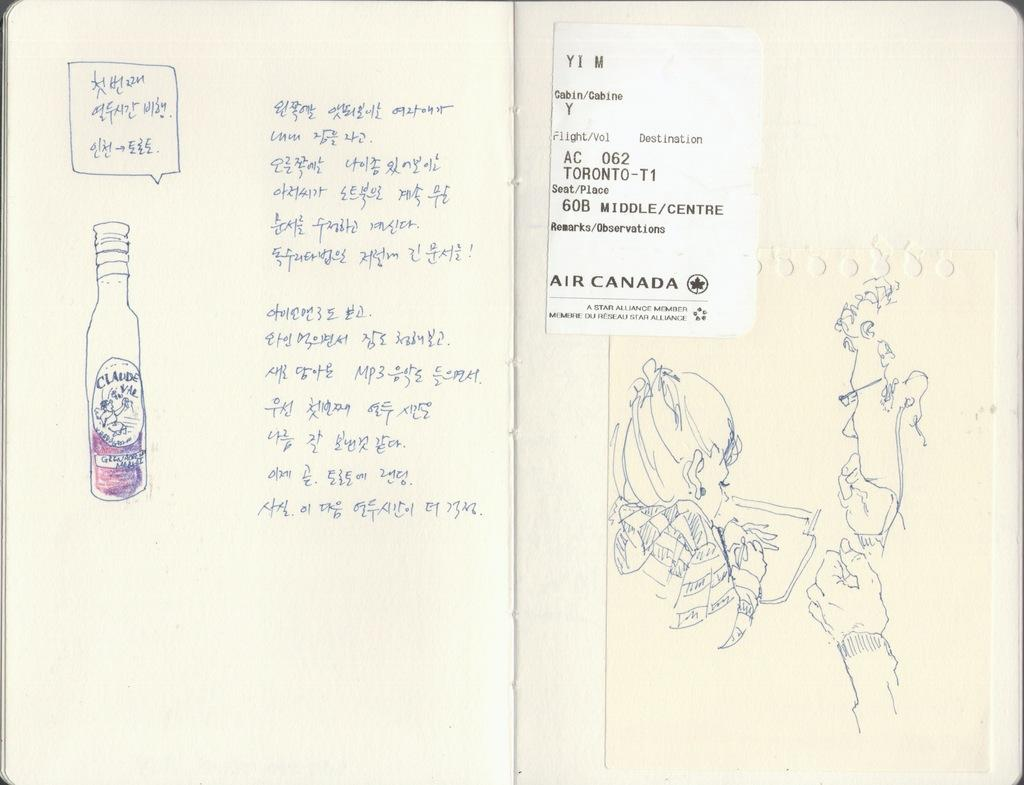<image>
Offer a succinct explanation of the picture presented. Foreign hand writing next to a hand drawn bottle and the other page has a hand drawn woman drawing. 